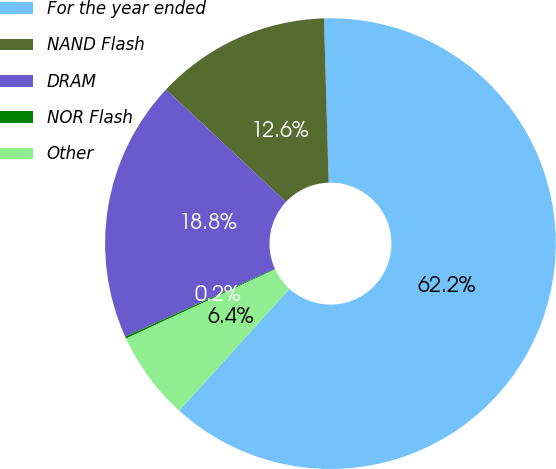<chart> <loc_0><loc_0><loc_500><loc_500><pie_chart><fcel>For the year ended<fcel>NAND Flash<fcel>DRAM<fcel>NOR Flash<fcel>Other<nl><fcel>62.17%<fcel>12.56%<fcel>18.76%<fcel>0.15%<fcel>6.36%<nl></chart> 